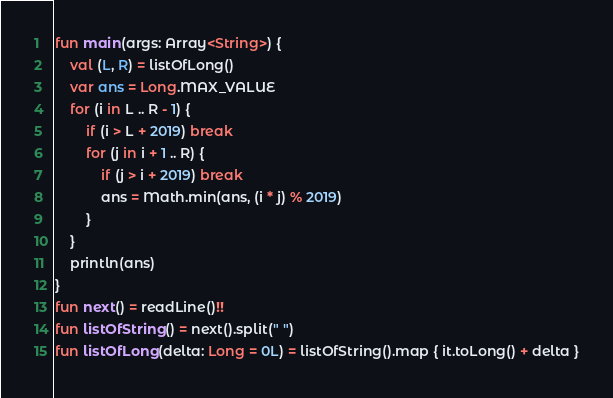<code> <loc_0><loc_0><loc_500><loc_500><_Kotlin_>fun main(args: Array<String>) {
    val (L, R) = listOfLong()
    var ans = Long.MAX_VALUE
    for (i in L .. R - 1) {
        if (i > L + 2019) break
        for (j in i + 1 .. R) {
            if (j > i + 2019) break
            ans = Math.min(ans, (i * j) % 2019)
        }
    }
    println(ans)
}
fun next() = readLine()!!
fun listOfString() = next().split(" ")
fun listOfLong(delta: Long = 0L) = listOfString().map { it.toLong() + delta }
</code> 